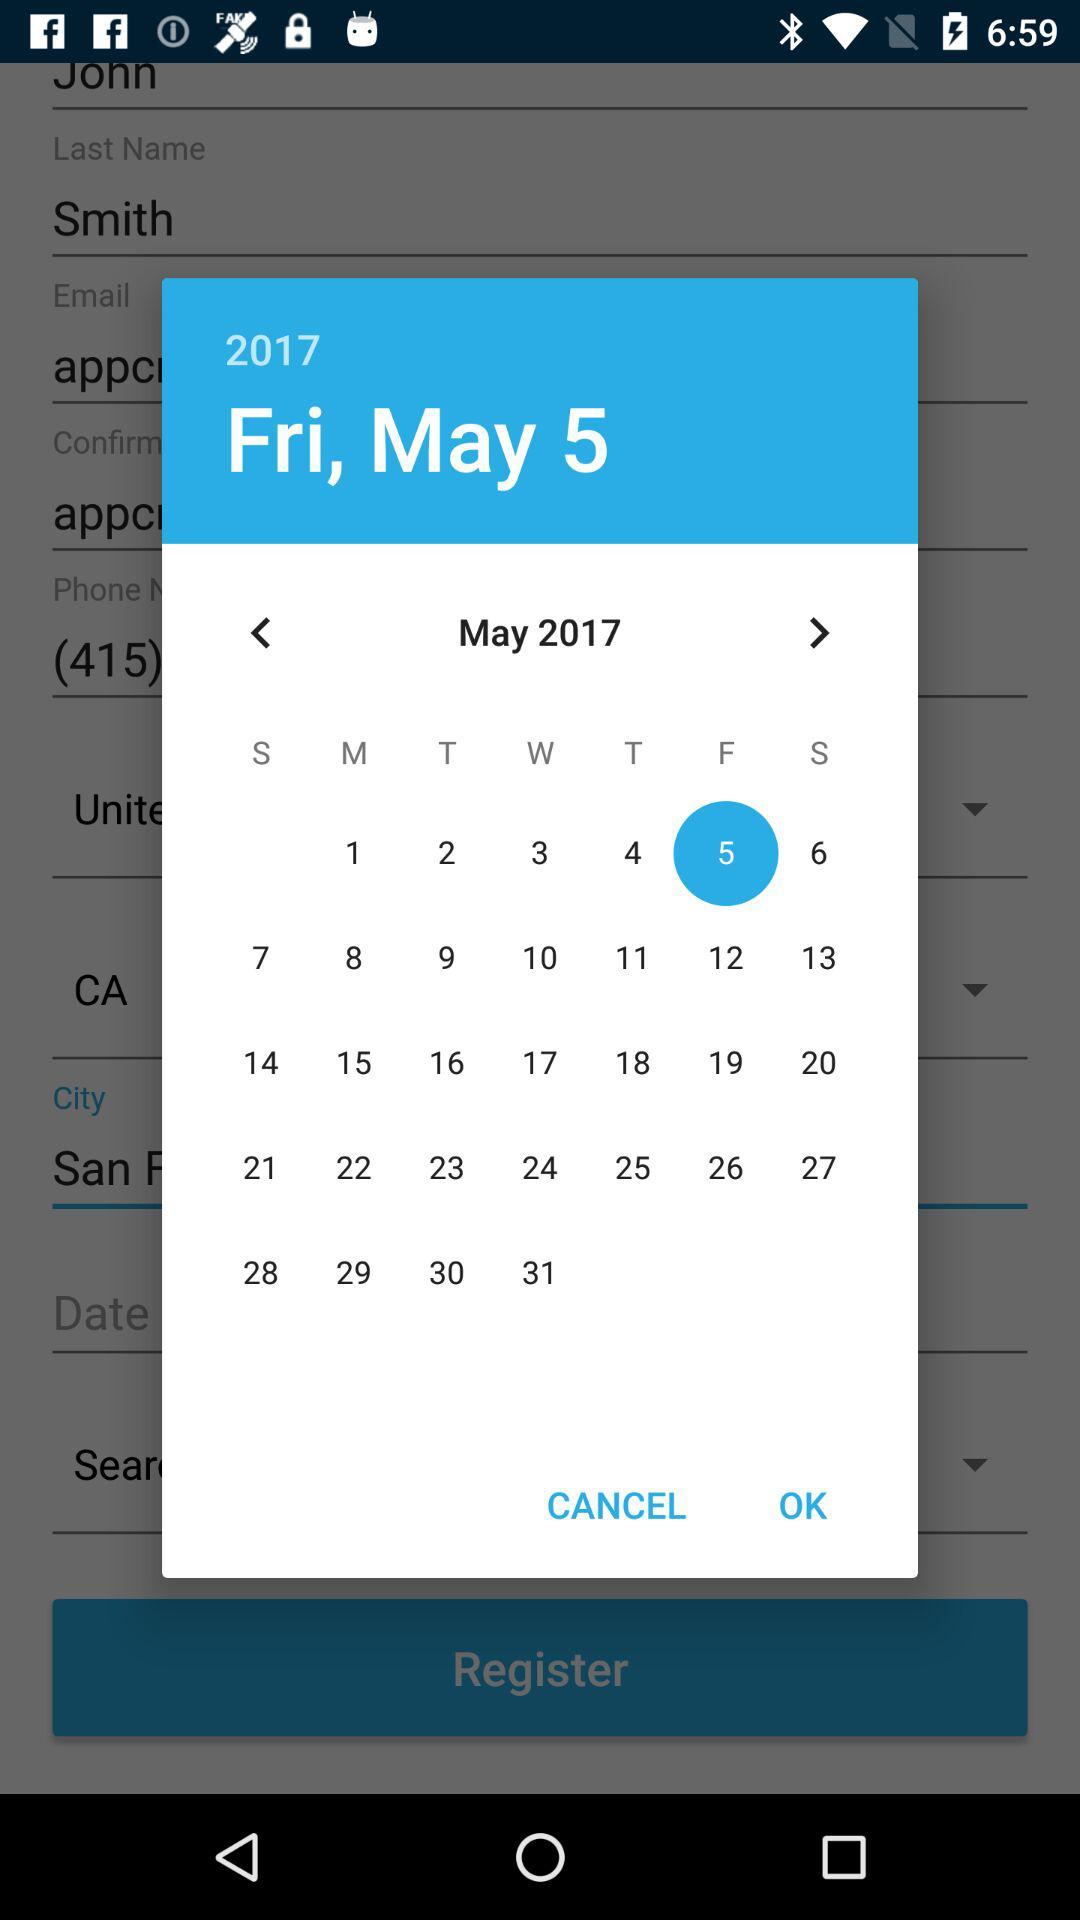What is the given year? The given year is 2017. 